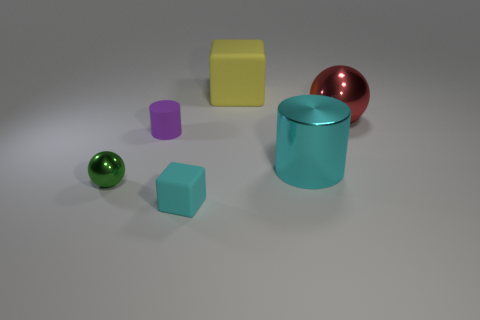What size is the shiny cylinder that is the same color as the tiny matte cube?
Offer a terse response. Large. Are there any cylinders that have the same color as the tiny cube?
Provide a short and direct response. Yes. What color is the metallic thing that is left of the cylinder that is behind the cyan thing that is right of the small rubber block?
Provide a succinct answer. Green. The cyan rubber thing is what shape?
Offer a very short reply. Cube. Do the large block and the block in front of the yellow rubber object have the same color?
Offer a very short reply. No. Are there the same number of matte objects to the left of the small matte cylinder and large yellow things?
Provide a succinct answer. No. What number of green things are the same size as the purple object?
Your response must be concise. 1. There is a large metal thing that is the same color as the small block; what shape is it?
Provide a succinct answer. Cylinder. Is there a small green metallic thing?
Your response must be concise. Yes. There is a green metal thing in front of the purple cylinder; is its shape the same as the cyan thing that is behind the green metal ball?
Provide a succinct answer. No. 